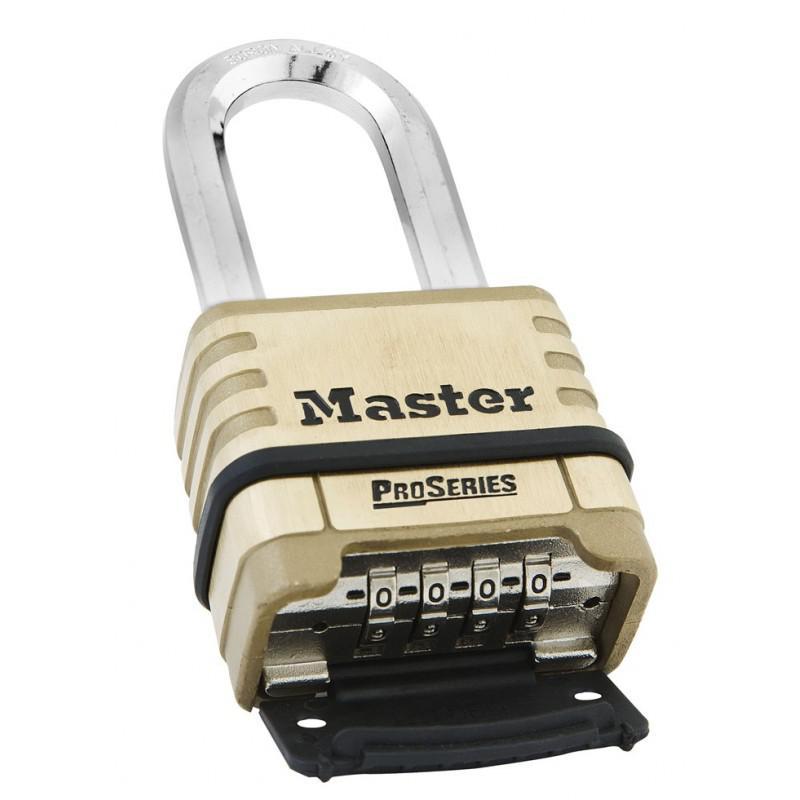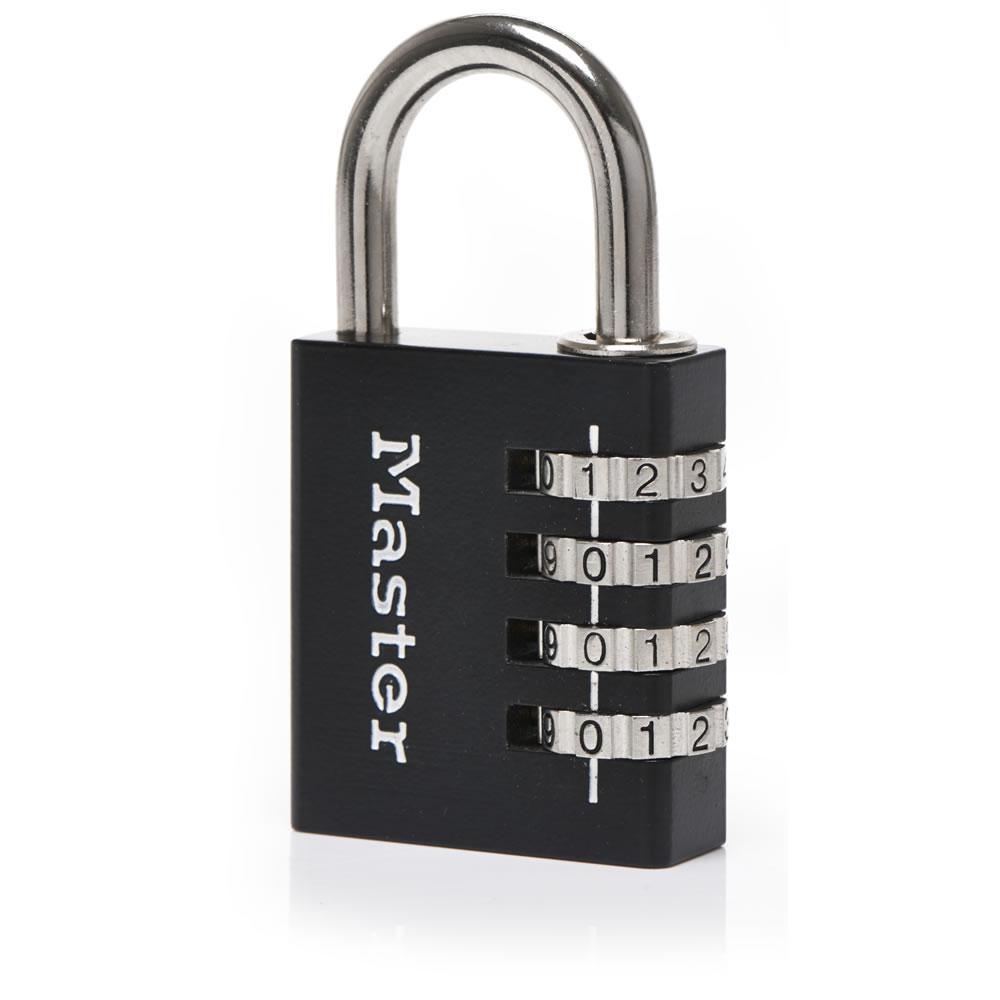The first image is the image on the left, the second image is the image on the right. Examine the images to the left and right. Is the description "One or more locks have their rotating discs showing on the side, while another lock does not have them on the side." accurate? Answer yes or no. Yes. The first image is the image on the left, the second image is the image on the right. Given the left and right images, does the statement "At least one of the locks has a black body with at least three rows of combination wheels on its front." hold true? Answer yes or no. Yes. 